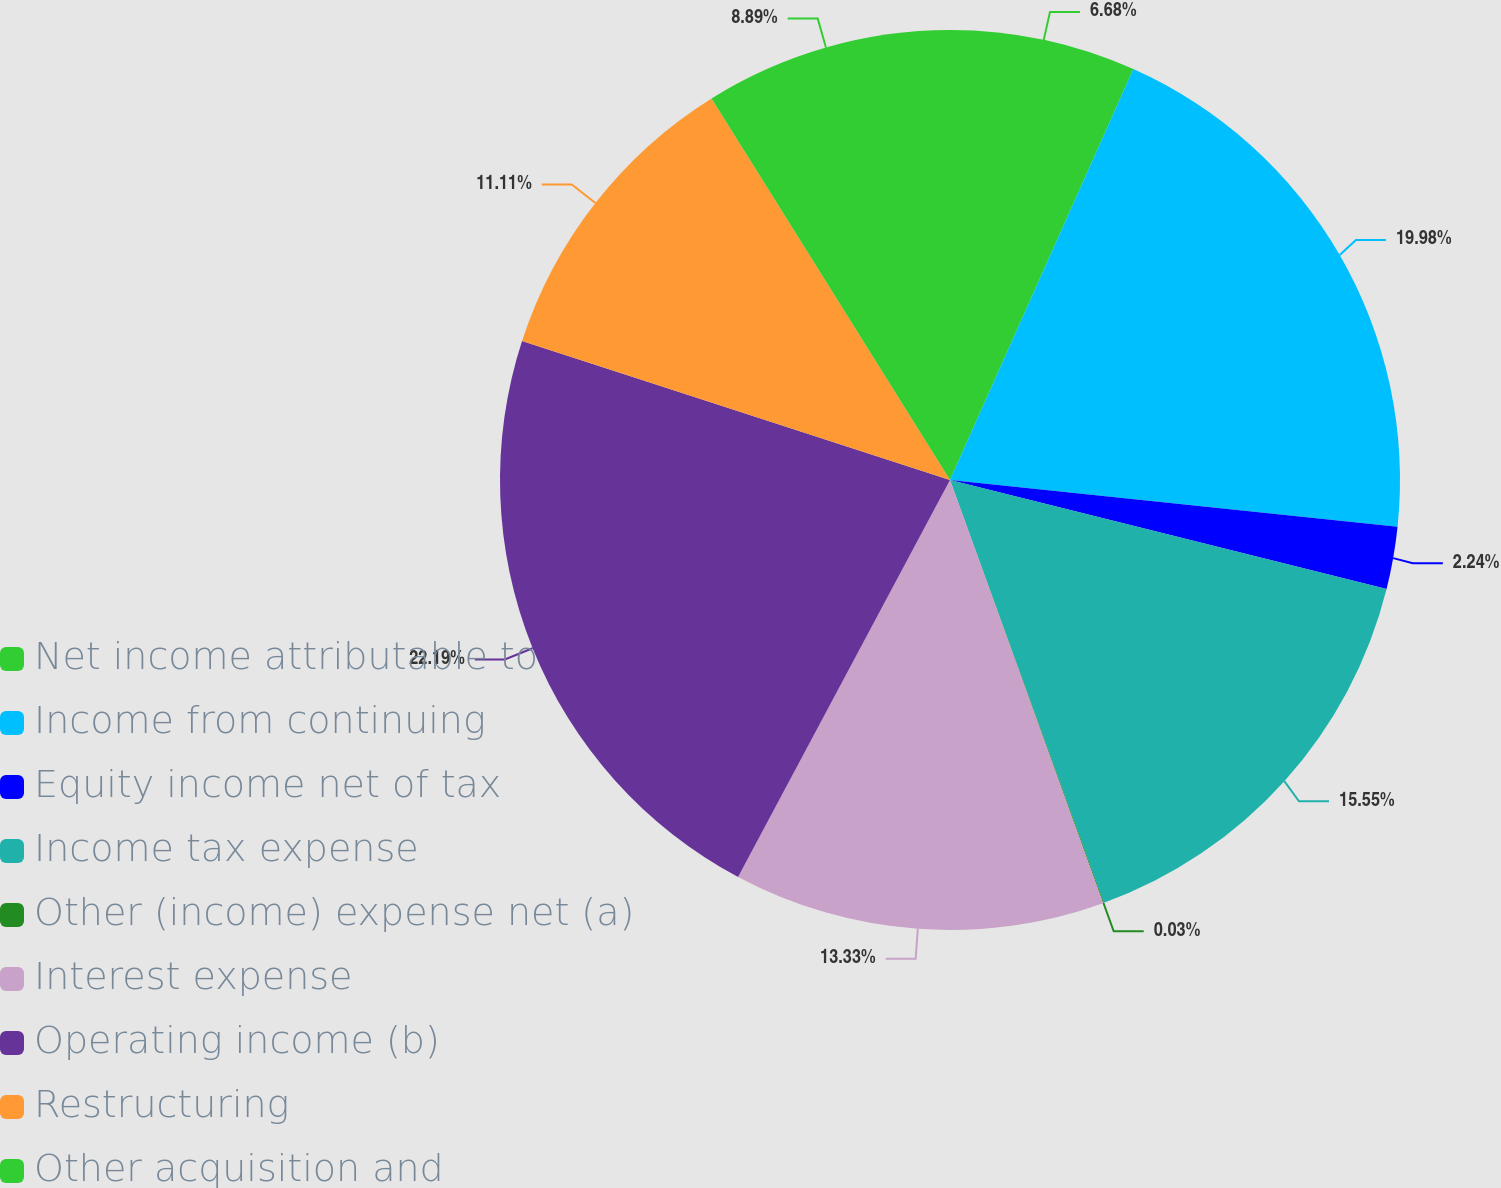Convert chart to OTSL. <chart><loc_0><loc_0><loc_500><loc_500><pie_chart><fcel>Net income attributable to<fcel>Income from continuing<fcel>Equity income net of tax<fcel>Income tax expense<fcel>Other (income) expense net (a)<fcel>Interest expense<fcel>Operating income (b)<fcel>Restructuring<fcel>Other acquisition and<nl><fcel>6.68%<fcel>19.98%<fcel>2.24%<fcel>15.55%<fcel>0.03%<fcel>13.33%<fcel>22.2%<fcel>11.11%<fcel>8.89%<nl></chart> 